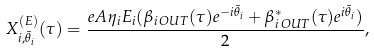Convert formula to latex. <formula><loc_0><loc_0><loc_500><loc_500>X _ { i , { \bar { \theta } _ { i } } } ^ { ( E ) } ( \tau ) = \frac { e A \eta _ { i } E _ { i } ( \beta _ { i \, O U T } ( \tau ) e ^ { - i { \bar { \theta } _ { i } } } + \beta _ { i \, O U T } ^ { * } ( \tau ) e ^ { i { \bar { \theta } _ { i } } } ) } { 2 } ,</formula> 